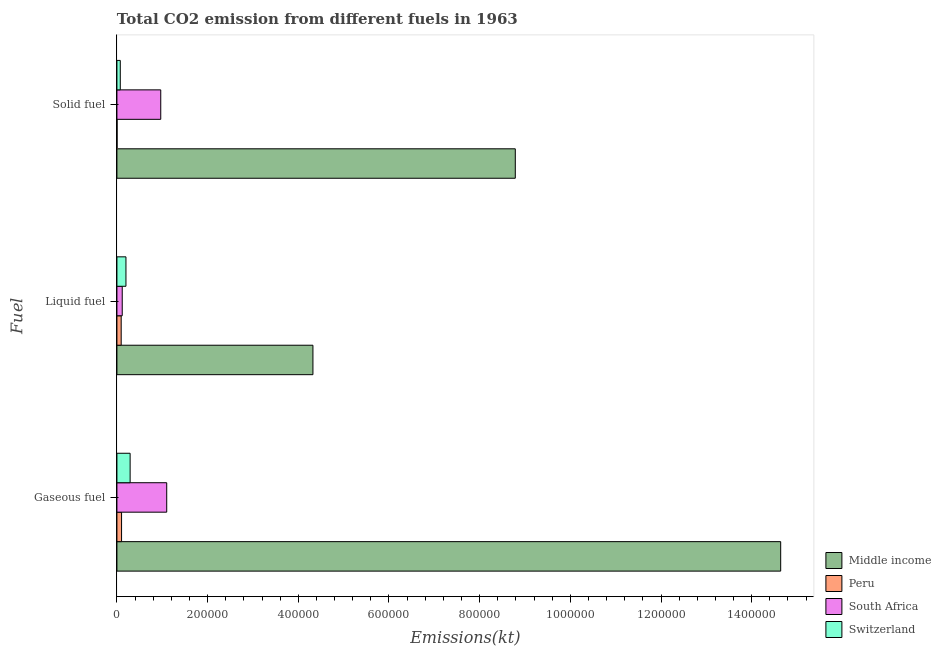How many different coloured bars are there?
Your answer should be compact. 4. How many bars are there on the 1st tick from the top?
Give a very brief answer. 4. How many bars are there on the 2nd tick from the bottom?
Your answer should be very brief. 4. What is the label of the 3rd group of bars from the top?
Offer a very short reply. Gaseous fuel. What is the amount of co2 emissions from solid fuel in Middle income?
Offer a terse response. 8.79e+05. Across all countries, what is the maximum amount of co2 emissions from gaseous fuel?
Keep it short and to the point. 1.46e+06. Across all countries, what is the minimum amount of co2 emissions from liquid fuel?
Your response must be concise. 9402.19. In which country was the amount of co2 emissions from solid fuel maximum?
Your response must be concise. Middle income. What is the total amount of co2 emissions from solid fuel in the graph?
Your answer should be very brief. 9.83e+05. What is the difference between the amount of co2 emissions from gaseous fuel in Middle income and that in Peru?
Offer a terse response. 1.45e+06. What is the difference between the amount of co2 emissions from gaseous fuel in Middle income and the amount of co2 emissions from liquid fuel in Peru?
Offer a terse response. 1.45e+06. What is the average amount of co2 emissions from gaseous fuel per country?
Provide a short and direct response. 4.03e+05. What is the difference between the amount of co2 emissions from gaseous fuel and amount of co2 emissions from liquid fuel in Switzerland?
Your answer should be very brief. 9196.84. In how many countries, is the amount of co2 emissions from liquid fuel greater than 1320000 kt?
Ensure brevity in your answer.  0. What is the ratio of the amount of co2 emissions from gaseous fuel in Peru to that in Switzerland?
Your response must be concise. 0.35. What is the difference between the highest and the second highest amount of co2 emissions from liquid fuel?
Your answer should be very brief. 4.12e+05. What is the difference between the highest and the lowest amount of co2 emissions from solid fuel?
Your answer should be compact. 8.78e+05. What does the 3rd bar from the top in Solid fuel represents?
Keep it short and to the point. Peru. What does the 4th bar from the bottom in Solid fuel represents?
Make the answer very short. Switzerland. How many bars are there?
Provide a short and direct response. 12. How many countries are there in the graph?
Provide a succinct answer. 4. What is the difference between two consecutive major ticks on the X-axis?
Make the answer very short. 2.00e+05. Does the graph contain any zero values?
Provide a short and direct response. No. How many legend labels are there?
Keep it short and to the point. 4. How are the legend labels stacked?
Keep it short and to the point. Vertical. What is the title of the graph?
Your answer should be very brief. Total CO2 emission from different fuels in 1963. Does "Slovak Republic" appear as one of the legend labels in the graph?
Provide a succinct answer. No. What is the label or title of the X-axis?
Make the answer very short. Emissions(kt). What is the label or title of the Y-axis?
Offer a very short reply. Fuel. What is the Emissions(kt) in Middle income in Gaseous fuel?
Provide a short and direct response. 1.46e+06. What is the Emissions(kt) in Peru in Gaseous fuel?
Keep it short and to the point. 1.02e+04. What is the Emissions(kt) of South Africa in Gaseous fuel?
Make the answer very short. 1.10e+05. What is the Emissions(kt) in Switzerland in Gaseous fuel?
Your response must be concise. 2.91e+04. What is the Emissions(kt) in Middle income in Liquid fuel?
Ensure brevity in your answer.  4.32e+05. What is the Emissions(kt) of Peru in Liquid fuel?
Make the answer very short. 9402.19. What is the Emissions(kt) in South Africa in Liquid fuel?
Keep it short and to the point. 1.17e+04. What is the Emissions(kt) in Switzerland in Liquid fuel?
Keep it short and to the point. 1.99e+04. What is the Emissions(kt) in Middle income in Solid fuel?
Your answer should be very brief. 8.79e+05. What is the Emissions(kt) of Peru in Solid fuel?
Keep it short and to the point. 319.03. What is the Emissions(kt) in South Africa in Solid fuel?
Provide a short and direct response. 9.67e+04. What is the Emissions(kt) in Switzerland in Solid fuel?
Provide a succinct answer. 7414.67. Across all Fuel, what is the maximum Emissions(kt) of Middle income?
Ensure brevity in your answer.  1.46e+06. Across all Fuel, what is the maximum Emissions(kt) in Peru?
Keep it short and to the point. 1.02e+04. Across all Fuel, what is the maximum Emissions(kt) of South Africa?
Give a very brief answer. 1.10e+05. Across all Fuel, what is the maximum Emissions(kt) of Switzerland?
Offer a very short reply. 2.91e+04. Across all Fuel, what is the minimum Emissions(kt) of Middle income?
Provide a short and direct response. 4.32e+05. Across all Fuel, what is the minimum Emissions(kt) of Peru?
Provide a short and direct response. 319.03. Across all Fuel, what is the minimum Emissions(kt) in South Africa?
Ensure brevity in your answer.  1.17e+04. Across all Fuel, what is the minimum Emissions(kt) in Switzerland?
Make the answer very short. 7414.67. What is the total Emissions(kt) of Middle income in the graph?
Offer a terse response. 2.77e+06. What is the total Emissions(kt) of Peru in the graph?
Ensure brevity in your answer.  2.00e+04. What is the total Emissions(kt) in South Africa in the graph?
Offer a terse response. 2.18e+05. What is the total Emissions(kt) of Switzerland in the graph?
Keep it short and to the point. 5.64e+04. What is the difference between the Emissions(kt) in Middle income in Gaseous fuel and that in Liquid fuel?
Keep it short and to the point. 1.03e+06. What is the difference between the Emissions(kt) in Peru in Gaseous fuel and that in Liquid fuel?
Provide a short and direct response. 832.41. What is the difference between the Emissions(kt) in South Africa in Gaseous fuel and that in Liquid fuel?
Offer a very short reply. 9.81e+04. What is the difference between the Emissions(kt) of Switzerland in Gaseous fuel and that in Liquid fuel?
Provide a succinct answer. 9196.84. What is the difference between the Emissions(kt) in Middle income in Gaseous fuel and that in Solid fuel?
Offer a terse response. 5.85e+05. What is the difference between the Emissions(kt) in Peru in Gaseous fuel and that in Solid fuel?
Keep it short and to the point. 9915.57. What is the difference between the Emissions(kt) in South Africa in Gaseous fuel and that in Solid fuel?
Offer a terse response. 1.31e+04. What is the difference between the Emissions(kt) of Switzerland in Gaseous fuel and that in Solid fuel?
Your response must be concise. 2.17e+04. What is the difference between the Emissions(kt) in Middle income in Liquid fuel and that in Solid fuel?
Your answer should be compact. -4.46e+05. What is the difference between the Emissions(kt) of Peru in Liquid fuel and that in Solid fuel?
Your answer should be compact. 9083.16. What is the difference between the Emissions(kt) in South Africa in Liquid fuel and that in Solid fuel?
Ensure brevity in your answer.  -8.50e+04. What is the difference between the Emissions(kt) of Switzerland in Liquid fuel and that in Solid fuel?
Make the answer very short. 1.25e+04. What is the difference between the Emissions(kt) of Middle income in Gaseous fuel and the Emissions(kt) of Peru in Liquid fuel?
Keep it short and to the point. 1.45e+06. What is the difference between the Emissions(kt) in Middle income in Gaseous fuel and the Emissions(kt) in South Africa in Liquid fuel?
Offer a very short reply. 1.45e+06. What is the difference between the Emissions(kt) in Middle income in Gaseous fuel and the Emissions(kt) in Switzerland in Liquid fuel?
Your answer should be compact. 1.44e+06. What is the difference between the Emissions(kt) of Peru in Gaseous fuel and the Emissions(kt) of South Africa in Liquid fuel?
Make the answer very short. -1470.47. What is the difference between the Emissions(kt) of Peru in Gaseous fuel and the Emissions(kt) of Switzerland in Liquid fuel?
Your answer should be compact. -9673.55. What is the difference between the Emissions(kt) in South Africa in Gaseous fuel and the Emissions(kt) in Switzerland in Liquid fuel?
Offer a very short reply. 8.99e+04. What is the difference between the Emissions(kt) of Middle income in Gaseous fuel and the Emissions(kt) of Peru in Solid fuel?
Offer a terse response. 1.46e+06. What is the difference between the Emissions(kt) in Middle income in Gaseous fuel and the Emissions(kt) in South Africa in Solid fuel?
Make the answer very short. 1.37e+06. What is the difference between the Emissions(kt) of Middle income in Gaseous fuel and the Emissions(kt) of Switzerland in Solid fuel?
Offer a terse response. 1.46e+06. What is the difference between the Emissions(kt) of Peru in Gaseous fuel and the Emissions(kt) of South Africa in Solid fuel?
Your response must be concise. -8.64e+04. What is the difference between the Emissions(kt) of Peru in Gaseous fuel and the Emissions(kt) of Switzerland in Solid fuel?
Provide a short and direct response. 2819.92. What is the difference between the Emissions(kt) of South Africa in Gaseous fuel and the Emissions(kt) of Switzerland in Solid fuel?
Offer a terse response. 1.02e+05. What is the difference between the Emissions(kt) in Middle income in Liquid fuel and the Emissions(kt) in Peru in Solid fuel?
Your answer should be very brief. 4.32e+05. What is the difference between the Emissions(kt) of Middle income in Liquid fuel and the Emissions(kt) of South Africa in Solid fuel?
Your answer should be compact. 3.36e+05. What is the difference between the Emissions(kt) in Middle income in Liquid fuel and the Emissions(kt) in Switzerland in Solid fuel?
Your answer should be compact. 4.25e+05. What is the difference between the Emissions(kt) in Peru in Liquid fuel and the Emissions(kt) in South Africa in Solid fuel?
Offer a terse response. -8.73e+04. What is the difference between the Emissions(kt) in Peru in Liquid fuel and the Emissions(kt) in Switzerland in Solid fuel?
Ensure brevity in your answer.  1987.51. What is the difference between the Emissions(kt) of South Africa in Liquid fuel and the Emissions(kt) of Switzerland in Solid fuel?
Ensure brevity in your answer.  4290.39. What is the average Emissions(kt) of Middle income per Fuel?
Your answer should be very brief. 9.25e+05. What is the average Emissions(kt) in Peru per Fuel?
Provide a short and direct response. 6651.94. What is the average Emissions(kt) in South Africa per Fuel?
Give a very brief answer. 7.27e+04. What is the average Emissions(kt) in Switzerland per Fuel?
Keep it short and to the point. 1.88e+04. What is the difference between the Emissions(kt) in Middle income and Emissions(kt) in Peru in Gaseous fuel?
Provide a short and direct response. 1.45e+06. What is the difference between the Emissions(kt) in Middle income and Emissions(kt) in South Africa in Gaseous fuel?
Keep it short and to the point. 1.35e+06. What is the difference between the Emissions(kt) in Middle income and Emissions(kt) in Switzerland in Gaseous fuel?
Your answer should be compact. 1.43e+06. What is the difference between the Emissions(kt) in Peru and Emissions(kt) in South Africa in Gaseous fuel?
Make the answer very short. -9.96e+04. What is the difference between the Emissions(kt) in Peru and Emissions(kt) in Switzerland in Gaseous fuel?
Make the answer very short. -1.89e+04. What is the difference between the Emissions(kt) in South Africa and Emissions(kt) in Switzerland in Gaseous fuel?
Provide a succinct answer. 8.07e+04. What is the difference between the Emissions(kt) of Middle income and Emissions(kt) of Peru in Liquid fuel?
Provide a short and direct response. 4.23e+05. What is the difference between the Emissions(kt) in Middle income and Emissions(kt) in South Africa in Liquid fuel?
Make the answer very short. 4.21e+05. What is the difference between the Emissions(kt) of Middle income and Emissions(kt) of Switzerland in Liquid fuel?
Give a very brief answer. 4.12e+05. What is the difference between the Emissions(kt) of Peru and Emissions(kt) of South Africa in Liquid fuel?
Your answer should be compact. -2302.88. What is the difference between the Emissions(kt) in Peru and Emissions(kt) in Switzerland in Liquid fuel?
Ensure brevity in your answer.  -1.05e+04. What is the difference between the Emissions(kt) of South Africa and Emissions(kt) of Switzerland in Liquid fuel?
Your answer should be very brief. -8203.08. What is the difference between the Emissions(kt) of Middle income and Emissions(kt) of Peru in Solid fuel?
Give a very brief answer. 8.78e+05. What is the difference between the Emissions(kt) in Middle income and Emissions(kt) in South Africa in Solid fuel?
Ensure brevity in your answer.  7.82e+05. What is the difference between the Emissions(kt) in Middle income and Emissions(kt) in Switzerland in Solid fuel?
Ensure brevity in your answer.  8.71e+05. What is the difference between the Emissions(kt) of Peru and Emissions(kt) of South Africa in Solid fuel?
Your answer should be compact. -9.64e+04. What is the difference between the Emissions(kt) in Peru and Emissions(kt) in Switzerland in Solid fuel?
Offer a terse response. -7095.65. What is the difference between the Emissions(kt) of South Africa and Emissions(kt) of Switzerland in Solid fuel?
Keep it short and to the point. 8.93e+04. What is the ratio of the Emissions(kt) in Middle income in Gaseous fuel to that in Liquid fuel?
Provide a short and direct response. 3.39. What is the ratio of the Emissions(kt) in Peru in Gaseous fuel to that in Liquid fuel?
Ensure brevity in your answer.  1.09. What is the ratio of the Emissions(kt) in South Africa in Gaseous fuel to that in Liquid fuel?
Provide a short and direct response. 9.38. What is the ratio of the Emissions(kt) in Switzerland in Gaseous fuel to that in Liquid fuel?
Ensure brevity in your answer.  1.46. What is the ratio of the Emissions(kt) of Middle income in Gaseous fuel to that in Solid fuel?
Provide a short and direct response. 1.67. What is the ratio of the Emissions(kt) of Peru in Gaseous fuel to that in Solid fuel?
Your answer should be very brief. 32.08. What is the ratio of the Emissions(kt) in South Africa in Gaseous fuel to that in Solid fuel?
Offer a terse response. 1.14. What is the ratio of the Emissions(kt) in Switzerland in Gaseous fuel to that in Solid fuel?
Your answer should be very brief. 3.93. What is the ratio of the Emissions(kt) in Middle income in Liquid fuel to that in Solid fuel?
Provide a succinct answer. 0.49. What is the ratio of the Emissions(kt) in Peru in Liquid fuel to that in Solid fuel?
Provide a short and direct response. 29.47. What is the ratio of the Emissions(kt) in South Africa in Liquid fuel to that in Solid fuel?
Give a very brief answer. 0.12. What is the ratio of the Emissions(kt) of Switzerland in Liquid fuel to that in Solid fuel?
Keep it short and to the point. 2.69. What is the difference between the highest and the second highest Emissions(kt) in Middle income?
Provide a succinct answer. 5.85e+05. What is the difference between the highest and the second highest Emissions(kt) in Peru?
Provide a succinct answer. 832.41. What is the difference between the highest and the second highest Emissions(kt) of South Africa?
Keep it short and to the point. 1.31e+04. What is the difference between the highest and the second highest Emissions(kt) of Switzerland?
Make the answer very short. 9196.84. What is the difference between the highest and the lowest Emissions(kt) of Middle income?
Provide a succinct answer. 1.03e+06. What is the difference between the highest and the lowest Emissions(kt) of Peru?
Provide a short and direct response. 9915.57. What is the difference between the highest and the lowest Emissions(kt) in South Africa?
Offer a terse response. 9.81e+04. What is the difference between the highest and the lowest Emissions(kt) in Switzerland?
Offer a terse response. 2.17e+04. 